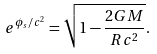Convert formula to latex. <formula><loc_0><loc_0><loc_500><loc_500>e ^ { \phi _ { s } / c ^ { 2 } } = \sqrt { 1 - \frac { 2 G M } { R c ^ { 2 } } } .</formula> 